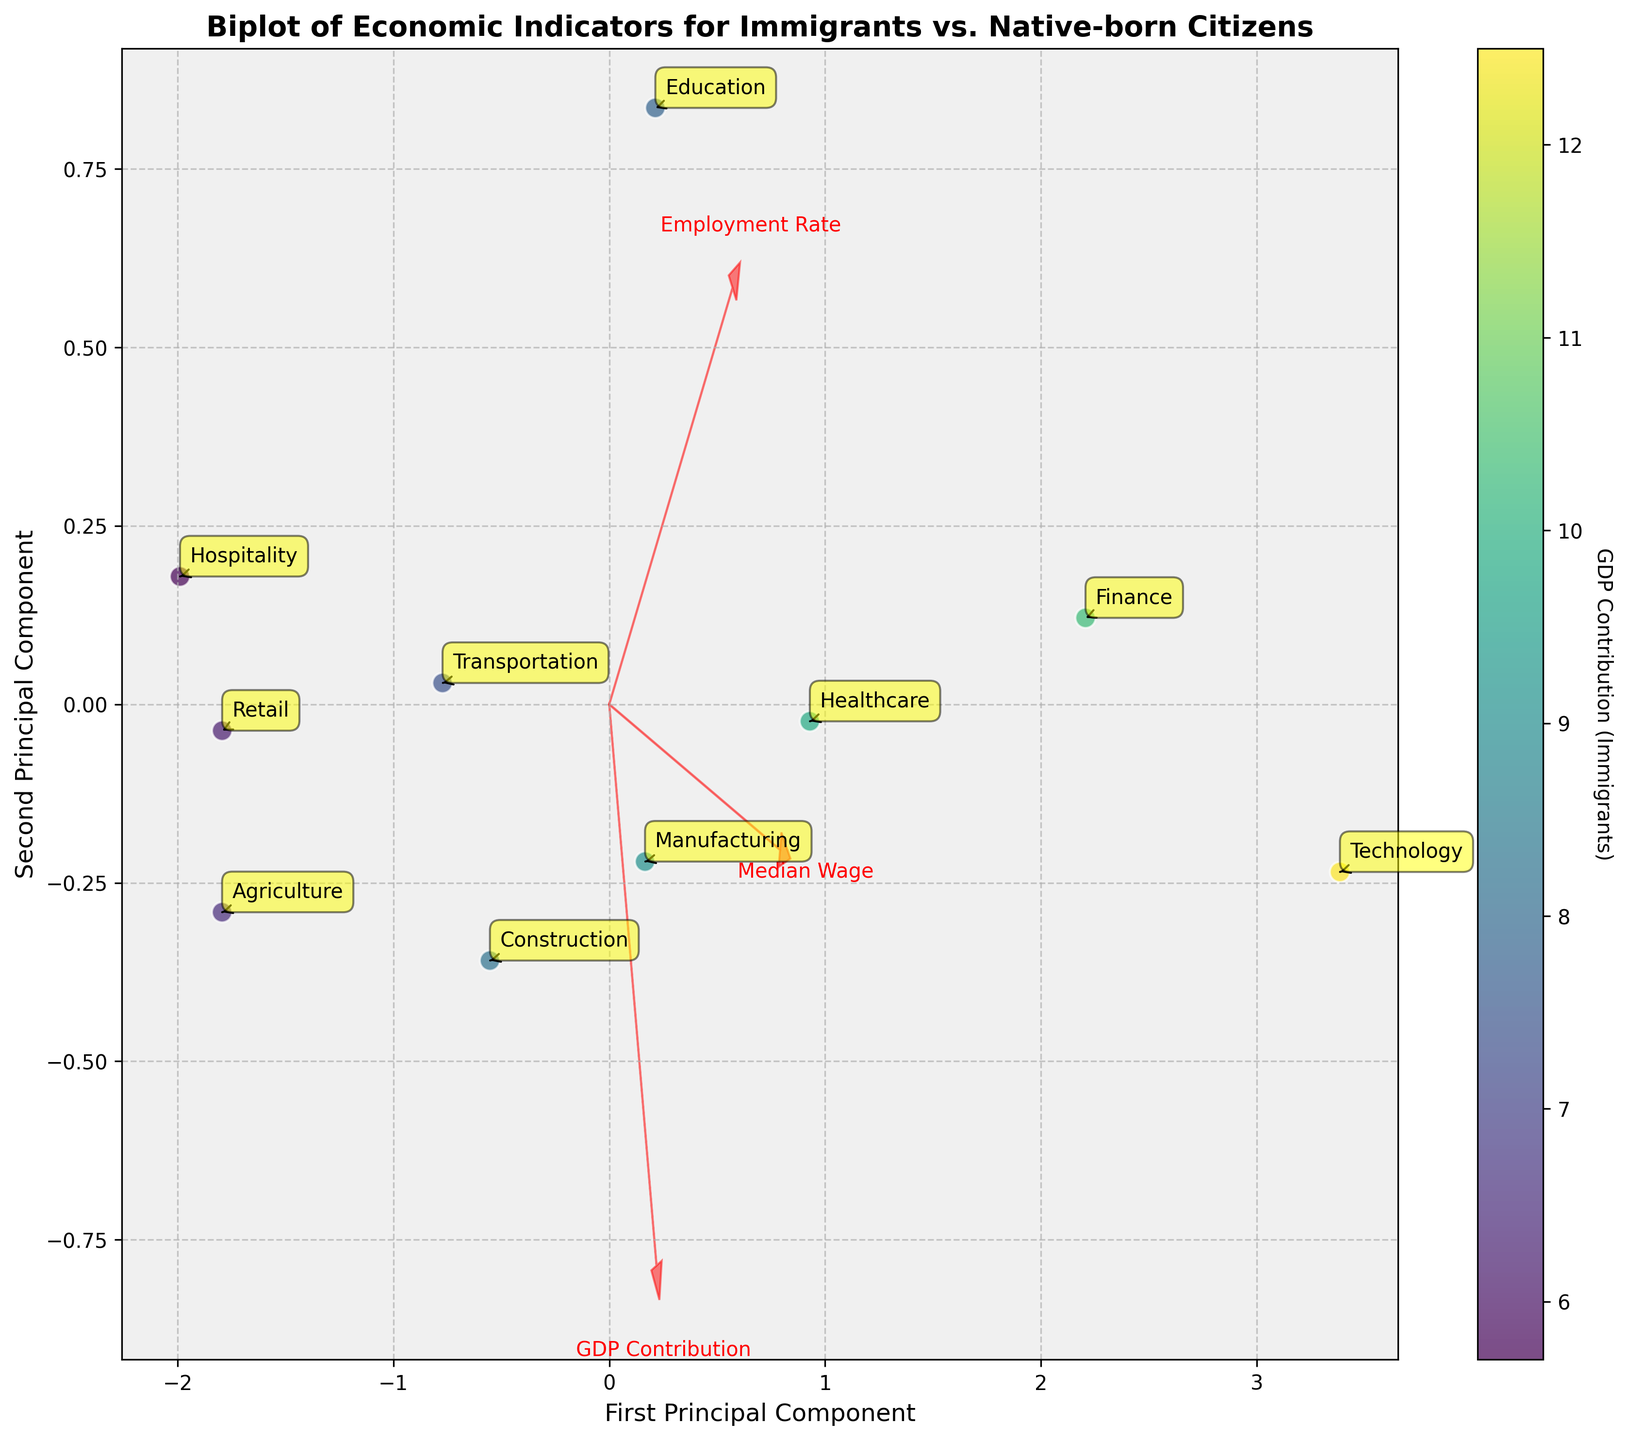How many industries are plotted in the biplot? Look at the number of annotated labels in the plot, each label represents an industry.
Answer: 10 What is the color representing in the scatter plot? Refer to the colorbar label on the right side of the plot to understand what it represents.
Answer: GDP Contribution (Immigrants) Which industry has the highest employment rate for immigrants? Identify the point furthest in the positive direction along the 'Employment Rate' vector, and find its label annotation.
Answer: Technology How does the GDP contribution of immigrants in the Education industry compare to that in Agriculture? Compare the position of the annotated points for 'Education' and 'Agriculture' relative to the GDP Contribution (Immigrants) color scale.
Answer: Education is higher What are the labels on the x-axis and y-axis? Check the labels written next to each axis to understand what each principal component represents.
Answer: First Principal Component, Second Principal Component Which industry has the smallest median wage for immigrants? Identify the point furthest in the negative direction along the 'Median Wage' vector, and find its label annotation.
Answer: Hospitality In which industry is the difference between the employment rate of immigrants and native-born citizens the greatest? Determine the annotated point with the greatest vertical distance between the 'Employment Rate' vector and its projection along the vector.
Answer: Agriculture Which features are represented by the red arrows, and what do they indicate? Read the text labels and observe the directions of the red arrows to understand their representation relative to the data points.
Answer: Employment Rate, Median Wage, GDP Contribution; they indicate the principal directions of maximum variance in the data If the employment rate for immigrants in retail was plotted at the origin, how would its position change on the biplot? Consider how the standardization process affects data points, and where a zero standard score would be plotted.
Answer: It would be located at (0,0) Based on the biplot, which two industries have the most similar economic indicators for immigrants? Look for two annotated points that are closest to each other on the plot.
Answer: Finance and Healthcare 